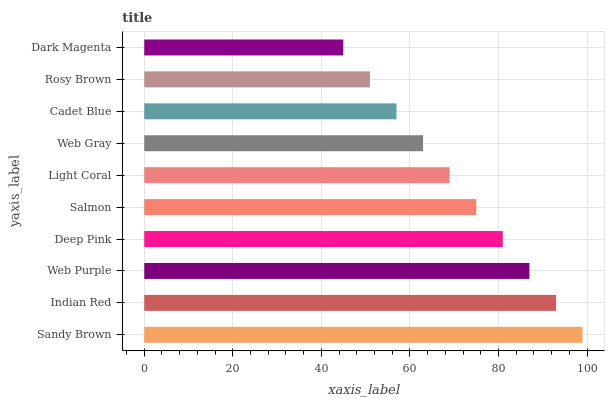Is Dark Magenta the minimum?
Answer yes or no. Yes. Is Sandy Brown the maximum?
Answer yes or no. Yes. Is Indian Red the minimum?
Answer yes or no. No. Is Indian Red the maximum?
Answer yes or no. No. Is Sandy Brown greater than Indian Red?
Answer yes or no. Yes. Is Indian Red less than Sandy Brown?
Answer yes or no. Yes. Is Indian Red greater than Sandy Brown?
Answer yes or no. No. Is Sandy Brown less than Indian Red?
Answer yes or no. No. Is Salmon the high median?
Answer yes or no. Yes. Is Light Coral the low median?
Answer yes or no. Yes. Is Deep Pink the high median?
Answer yes or no. No. Is Web Gray the low median?
Answer yes or no. No. 